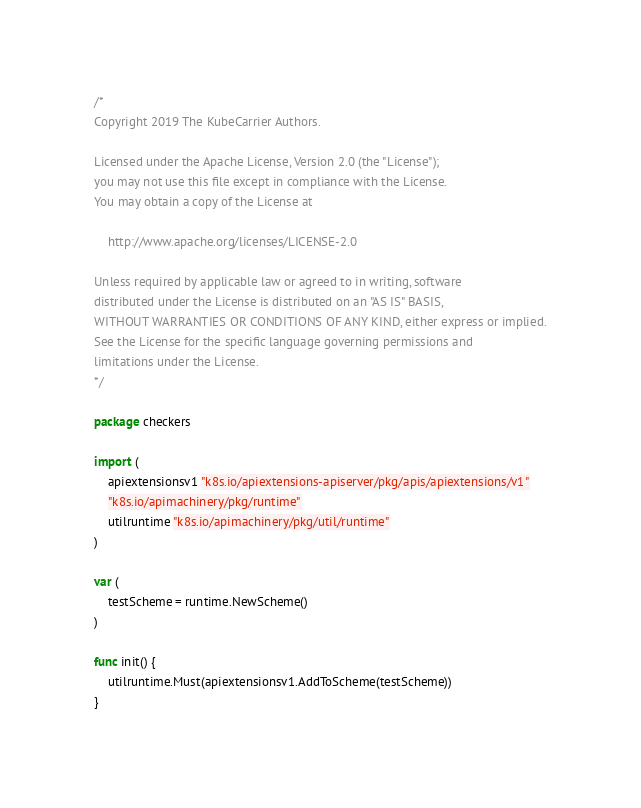Convert code to text. <code><loc_0><loc_0><loc_500><loc_500><_Go_>/*
Copyright 2019 The KubeCarrier Authors.

Licensed under the Apache License, Version 2.0 (the "License");
you may not use this file except in compliance with the License.
You may obtain a copy of the License at

    http://www.apache.org/licenses/LICENSE-2.0

Unless required by applicable law or agreed to in writing, software
distributed under the License is distributed on an "AS IS" BASIS,
WITHOUT WARRANTIES OR CONDITIONS OF ANY KIND, either express or implied.
See the License for the specific language governing permissions and
limitations under the License.
*/

package checkers

import (
	apiextensionsv1 "k8s.io/apiextensions-apiserver/pkg/apis/apiextensions/v1"
	"k8s.io/apimachinery/pkg/runtime"
	utilruntime "k8s.io/apimachinery/pkg/util/runtime"
)

var (
	testScheme = runtime.NewScheme()
)

func init() {
	utilruntime.Must(apiextensionsv1.AddToScheme(testScheme))
}
</code> 